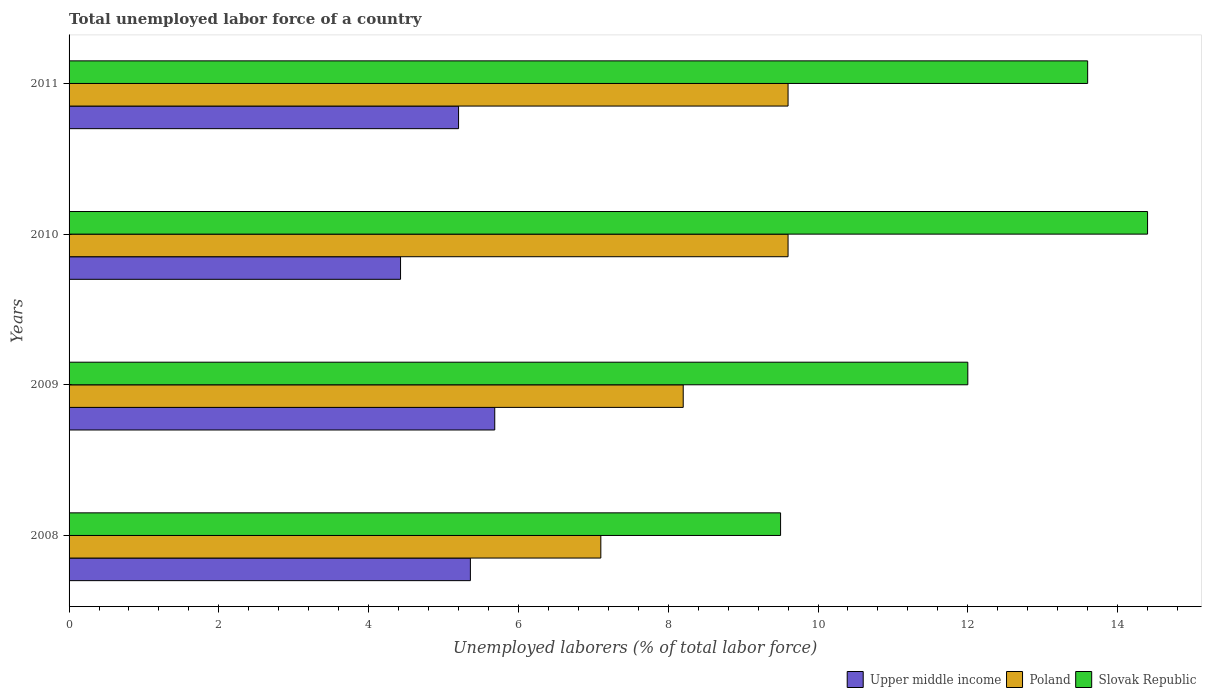Are the number of bars on each tick of the Y-axis equal?
Offer a terse response. Yes. How many bars are there on the 3rd tick from the bottom?
Make the answer very short. 3. In how many cases, is the number of bars for a given year not equal to the number of legend labels?
Make the answer very short. 0. What is the total unemployed labor force in Upper middle income in 2011?
Your answer should be compact. 5.2. Across all years, what is the maximum total unemployed labor force in Slovak Republic?
Provide a short and direct response. 14.4. Across all years, what is the minimum total unemployed labor force in Upper middle income?
Keep it short and to the point. 4.43. In which year was the total unemployed labor force in Poland maximum?
Offer a terse response. 2010. What is the total total unemployed labor force in Poland in the graph?
Make the answer very short. 34.5. What is the difference between the total unemployed labor force in Poland in 2008 and that in 2011?
Offer a very short reply. -2.5. What is the difference between the total unemployed labor force in Poland in 2009 and the total unemployed labor force in Slovak Republic in 2008?
Keep it short and to the point. -1.3. What is the average total unemployed labor force in Slovak Republic per year?
Provide a succinct answer. 12.38. In the year 2008, what is the difference between the total unemployed labor force in Poland and total unemployed labor force in Slovak Republic?
Make the answer very short. -2.4. What is the ratio of the total unemployed labor force in Upper middle income in 2009 to that in 2011?
Keep it short and to the point. 1.09. Is the total unemployed labor force in Poland in 2008 less than that in 2009?
Keep it short and to the point. Yes. What is the difference between the highest and the second highest total unemployed labor force in Upper middle income?
Provide a short and direct response. 0.33. What is the difference between the highest and the lowest total unemployed labor force in Poland?
Offer a terse response. 2.5. In how many years, is the total unemployed labor force in Upper middle income greater than the average total unemployed labor force in Upper middle income taken over all years?
Offer a terse response. 3. Is the sum of the total unemployed labor force in Slovak Republic in 2008 and 2009 greater than the maximum total unemployed labor force in Upper middle income across all years?
Your response must be concise. Yes. What does the 3rd bar from the top in 2011 represents?
Make the answer very short. Upper middle income. What does the 3rd bar from the bottom in 2008 represents?
Keep it short and to the point. Slovak Republic. Is it the case that in every year, the sum of the total unemployed labor force in Slovak Republic and total unemployed labor force in Poland is greater than the total unemployed labor force in Upper middle income?
Your answer should be very brief. Yes. How many bars are there?
Keep it short and to the point. 12. Are all the bars in the graph horizontal?
Provide a short and direct response. Yes. Are the values on the major ticks of X-axis written in scientific E-notation?
Provide a succinct answer. No. Does the graph contain any zero values?
Your answer should be very brief. No. Does the graph contain grids?
Offer a very short reply. No. Where does the legend appear in the graph?
Your response must be concise. Bottom right. How are the legend labels stacked?
Make the answer very short. Horizontal. What is the title of the graph?
Provide a short and direct response. Total unemployed labor force of a country. Does "Rwanda" appear as one of the legend labels in the graph?
Provide a short and direct response. No. What is the label or title of the X-axis?
Give a very brief answer. Unemployed laborers (% of total labor force). What is the label or title of the Y-axis?
Offer a very short reply. Years. What is the Unemployed laborers (% of total labor force) in Upper middle income in 2008?
Provide a succinct answer. 5.36. What is the Unemployed laborers (% of total labor force) of Poland in 2008?
Your answer should be compact. 7.1. What is the Unemployed laborers (% of total labor force) of Upper middle income in 2009?
Your answer should be very brief. 5.68. What is the Unemployed laborers (% of total labor force) in Poland in 2009?
Offer a very short reply. 8.2. What is the Unemployed laborers (% of total labor force) in Slovak Republic in 2009?
Your answer should be compact. 12. What is the Unemployed laborers (% of total labor force) of Upper middle income in 2010?
Your response must be concise. 4.43. What is the Unemployed laborers (% of total labor force) of Poland in 2010?
Ensure brevity in your answer.  9.6. What is the Unemployed laborers (% of total labor force) in Slovak Republic in 2010?
Keep it short and to the point. 14.4. What is the Unemployed laborers (% of total labor force) of Upper middle income in 2011?
Give a very brief answer. 5.2. What is the Unemployed laborers (% of total labor force) of Poland in 2011?
Provide a short and direct response. 9.6. What is the Unemployed laborers (% of total labor force) of Slovak Republic in 2011?
Keep it short and to the point. 13.6. Across all years, what is the maximum Unemployed laborers (% of total labor force) in Upper middle income?
Give a very brief answer. 5.68. Across all years, what is the maximum Unemployed laborers (% of total labor force) of Poland?
Offer a terse response. 9.6. Across all years, what is the maximum Unemployed laborers (% of total labor force) in Slovak Republic?
Your response must be concise. 14.4. Across all years, what is the minimum Unemployed laborers (% of total labor force) in Upper middle income?
Ensure brevity in your answer.  4.43. Across all years, what is the minimum Unemployed laborers (% of total labor force) of Poland?
Your answer should be very brief. 7.1. Across all years, what is the minimum Unemployed laborers (% of total labor force) in Slovak Republic?
Provide a short and direct response. 9.5. What is the total Unemployed laborers (% of total labor force) in Upper middle income in the graph?
Keep it short and to the point. 20.67. What is the total Unemployed laborers (% of total labor force) in Poland in the graph?
Give a very brief answer. 34.5. What is the total Unemployed laborers (% of total labor force) in Slovak Republic in the graph?
Your response must be concise. 49.5. What is the difference between the Unemployed laborers (% of total labor force) in Upper middle income in 2008 and that in 2009?
Offer a terse response. -0.33. What is the difference between the Unemployed laborers (% of total labor force) of Poland in 2008 and that in 2009?
Offer a terse response. -1.1. What is the difference between the Unemployed laborers (% of total labor force) in Upper middle income in 2008 and that in 2010?
Your answer should be compact. 0.93. What is the difference between the Unemployed laborers (% of total labor force) of Upper middle income in 2008 and that in 2011?
Provide a succinct answer. 0.16. What is the difference between the Unemployed laborers (% of total labor force) of Slovak Republic in 2008 and that in 2011?
Keep it short and to the point. -4.1. What is the difference between the Unemployed laborers (% of total labor force) in Upper middle income in 2009 and that in 2010?
Offer a very short reply. 1.26. What is the difference between the Unemployed laborers (% of total labor force) in Slovak Republic in 2009 and that in 2010?
Make the answer very short. -2.4. What is the difference between the Unemployed laborers (% of total labor force) in Upper middle income in 2009 and that in 2011?
Ensure brevity in your answer.  0.48. What is the difference between the Unemployed laborers (% of total labor force) of Poland in 2009 and that in 2011?
Give a very brief answer. -1.4. What is the difference between the Unemployed laborers (% of total labor force) of Upper middle income in 2010 and that in 2011?
Ensure brevity in your answer.  -0.77. What is the difference between the Unemployed laborers (% of total labor force) in Poland in 2010 and that in 2011?
Your response must be concise. 0. What is the difference between the Unemployed laborers (% of total labor force) in Upper middle income in 2008 and the Unemployed laborers (% of total labor force) in Poland in 2009?
Provide a short and direct response. -2.84. What is the difference between the Unemployed laborers (% of total labor force) of Upper middle income in 2008 and the Unemployed laborers (% of total labor force) of Slovak Republic in 2009?
Give a very brief answer. -6.64. What is the difference between the Unemployed laborers (% of total labor force) of Upper middle income in 2008 and the Unemployed laborers (% of total labor force) of Poland in 2010?
Your answer should be compact. -4.24. What is the difference between the Unemployed laborers (% of total labor force) of Upper middle income in 2008 and the Unemployed laborers (% of total labor force) of Slovak Republic in 2010?
Your response must be concise. -9.04. What is the difference between the Unemployed laborers (% of total labor force) of Poland in 2008 and the Unemployed laborers (% of total labor force) of Slovak Republic in 2010?
Your answer should be very brief. -7.3. What is the difference between the Unemployed laborers (% of total labor force) of Upper middle income in 2008 and the Unemployed laborers (% of total labor force) of Poland in 2011?
Offer a very short reply. -4.24. What is the difference between the Unemployed laborers (% of total labor force) in Upper middle income in 2008 and the Unemployed laborers (% of total labor force) in Slovak Republic in 2011?
Give a very brief answer. -8.24. What is the difference between the Unemployed laborers (% of total labor force) in Upper middle income in 2009 and the Unemployed laborers (% of total labor force) in Poland in 2010?
Offer a very short reply. -3.92. What is the difference between the Unemployed laborers (% of total labor force) in Upper middle income in 2009 and the Unemployed laborers (% of total labor force) in Slovak Republic in 2010?
Your answer should be compact. -8.72. What is the difference between the Unemployed laborers (% of total labor force) in Poland in 2009 and the Unemployed laborers (% of total labor force) in Slovak Republic in 2010?
Make the answer very short. -6.2. What is the difference between the Unemployed laborers (% of total labor force) in Upper middle income in 2009 and the Unemployed laborers (% of total labor force) in Poland in 2011?
Your response must be concise. -3.92. What is the difference between the Unemployed laborers (% of total labor force) in Upper middle income in 2009 and the Unemployed laborers (% of total labor force) in Slovak Republic in 2011?
Offer a very short reply. -7.92. What is the difference between the Unemployed laborers (% of total labor force) in Upper middle income in 2010 and the Unemployed laborers (% of total labor force) in Poland in 2011?
Ensure brevity in your answer.  -5.17. What is the difference between the Unemployed laborers (% of total labor force) of Upper middle income in 2010 and the Unemployed laborers (% of total labor force) of Slovak Republic in 2011?
Your answer should be compact. -9.17. What is the difference between the Unemployed laborers (% of total labor force) in Poland in 2010 and the Unemployed laborers (% of total labor force) in Slovak Republic in 2011?
Your answer should be very brief. -4. What is the average Unemployed laborers (% of total labor force) in Upper middle income per year?
Your answer should be compact. 5.17. What is the average Unemployed laborers (% of total labor force) in Poland per year?
Give a very brief answer. 8.62. What is the average Unemployed laborers (% of total labor force) in Slovak Republic per year?
Give a very brief answer. 12.38. In the year 2008, what is the difference between the Unemployed laborers (% of total labor force) in Upper middle income and Unemployed laborers (% of total labor force) in Poland?
Offer a terse response. -1.74. In the year 2008, what is the difference between the Unemployed laborers (% of total labor force) in Upper middle income and Unemployed laborers (% of total labor force) in Slovak Republic?
Offer a terse response. -4.14. In the year 2008, what is the difference between the Unemployed laborers (% of total labor force) of Poland and Unemployed laborers (% of total labor force) of Slovak Republic?
Offer a terse response. -2.4. In the year 2009, what is the difference between the Unemployed laborers (% of total labor force) of Upper middle income and Unemployed laborers (% of total labor force) of Poland?
Provide a short and direct response. -2.52. In the year 2009, what is the difference between the Unemployed laborers (% of total labor force) in Upper middle income and Unemployed laborers (% of total labor force) in Slovak Republic?
Provide a succinct answer. -6.32. In the year 2010, what is the difference between the Unemployed laborers (% of total labor force) of Upper middle income and Unemployed laborers (% of total labor force) of Poland?
Ensure brevity in your answer.  -5.17. In the year 2010, what is the difference between the Unemployed laborers (% of total labor force) in Upper middle income and Unemployed laborers (% of total labor force) in Slovak Republic?
Your answer should be very brief. -9.97. In the year 2010, what is the difference between the Unemployed laborers (% of total labor force) in Poland and Unemployed laborers (% of total labor force) in Slovak Republic?
Your response must be concise. -4.8. In the year 2011, what is the difference between the Unemployed laborers (% of total labor force) in Upper middle income and Unemployed laborers (% of total labor force) in Poland?
Offer a very short reply. -4.4. In the year 2011, what is the difference between the Unemployed laborers (% of total labor force) of Upper middle income and Unemployed laborers (% of total labor force) of Slovak Republic?
Offer a very short reply. -8.4. In the year 2011, what is the difference between the Unemployed laborers (% of total labor force) in Poland and Unemployed laborers (% of total labor force) in Slovak Republic?
Your answer should be very brief. -4. What is the ratio of the Unemployed laborers (% of total labor force) in Upper middle income in 2008 to that in 2009?
Offer a very short reply. 0.94. What is the ratio of the Unemployed laborers (% of total labor force) of Poland in 2008 to that in 2009?
Keep it short and to the point. 0.87. What is the ratio of the Unemployed laborers (% of total labor force) of Slovak Republic in 2008 to that in 2009?
Provide a succinct answer. 0.79. What is the ratio of the Unemployed laborers (% of total labor force) of Upper middle income in 2008 to that in 2010?
Ensure brevity in your answer.  1.21. What is the ratio of the Unemployed laborers (% of total labor force) in Poland in 2008 to that in 2010?
Your answer should be compact. 0.74. What is the ratio of the Unemployed laborers (% of total labor force) of Slovak Republic in 2008 to that in 2010?
Make the answer very short. 0.66. What is the ratio of the Unemployed laborers (% of total labor force) in Upper middle income in 2008 to that in 2011?
Your answer should be compact. 1.03. What is the ratio of the Unemployed laborers (% of total labor force) of Poland in 2008 to that in 2011?
Give a very brief answer. 0.74. What is the ratio of the Unemployed laborers (% of total labor force) of Slovak Republic in 2008 to that in 2011?
Your answer should be compact. 0.7. What is the ratio of the Unemployed laborers (% of total labor force) in Upper middle income in 2009 to that in 2010?
Provide a succinct answer. 1.28. What is the ratio of the Unemployed laborers (% of total labor force) of Poland in 2009 to that in 2010?
Your response must be concise. 0.85. What is the ratio of the Unemployed laborers (% of total labor force) in Slovak Republic in 2009 to that in 2010?
Your answer should be very brief. 0.83. What is the ratio of the Unemployed laborers (% of total labor force) in Upper middle income in 2009 to that in 2011?
Make the answer very short. 1.09. What is the ratio of the Unemployed laborers (% of total labor force) in Poland in 2009 to that in 2011?
Your answer should be compact. 0.85. What is the ratio of the Unemployed laborers (% of total labor force) in Slovak Republic in 2009 to that in 2011?
Ensure brevity in your answer.  0.88. What is the ratio of the Unemployed laborers (% of total labor force) in Upper middle income in 2010 to that in 2011?
Your answer should be compact. 0.85. What is the ratio of the Unemployed laborers (% of total labor force) of Poland in 2010 to that in 2011?
Give a very brief answer. 1. What is the ratio of the Unemployed laborers (% of total labor force) of Slovak Republic in 2010 to that in 2011?
Your answer should be very brief. 1.06. What is the difference between the highest and the second highest Unemployed laborers (% of total labor force) in Upper middle income?
Keep it short and to the point. 0.33. What is the difference between the highest and the lowest Unemployed laborers (% of total labor force) of Upper middle income?
Keep it short and to the point. 1.26. What is the difference between the highest and the lowest Unemployed laborers (% of total labor force) in Slovak Republic?
Offer a very short reply. 4.9. 